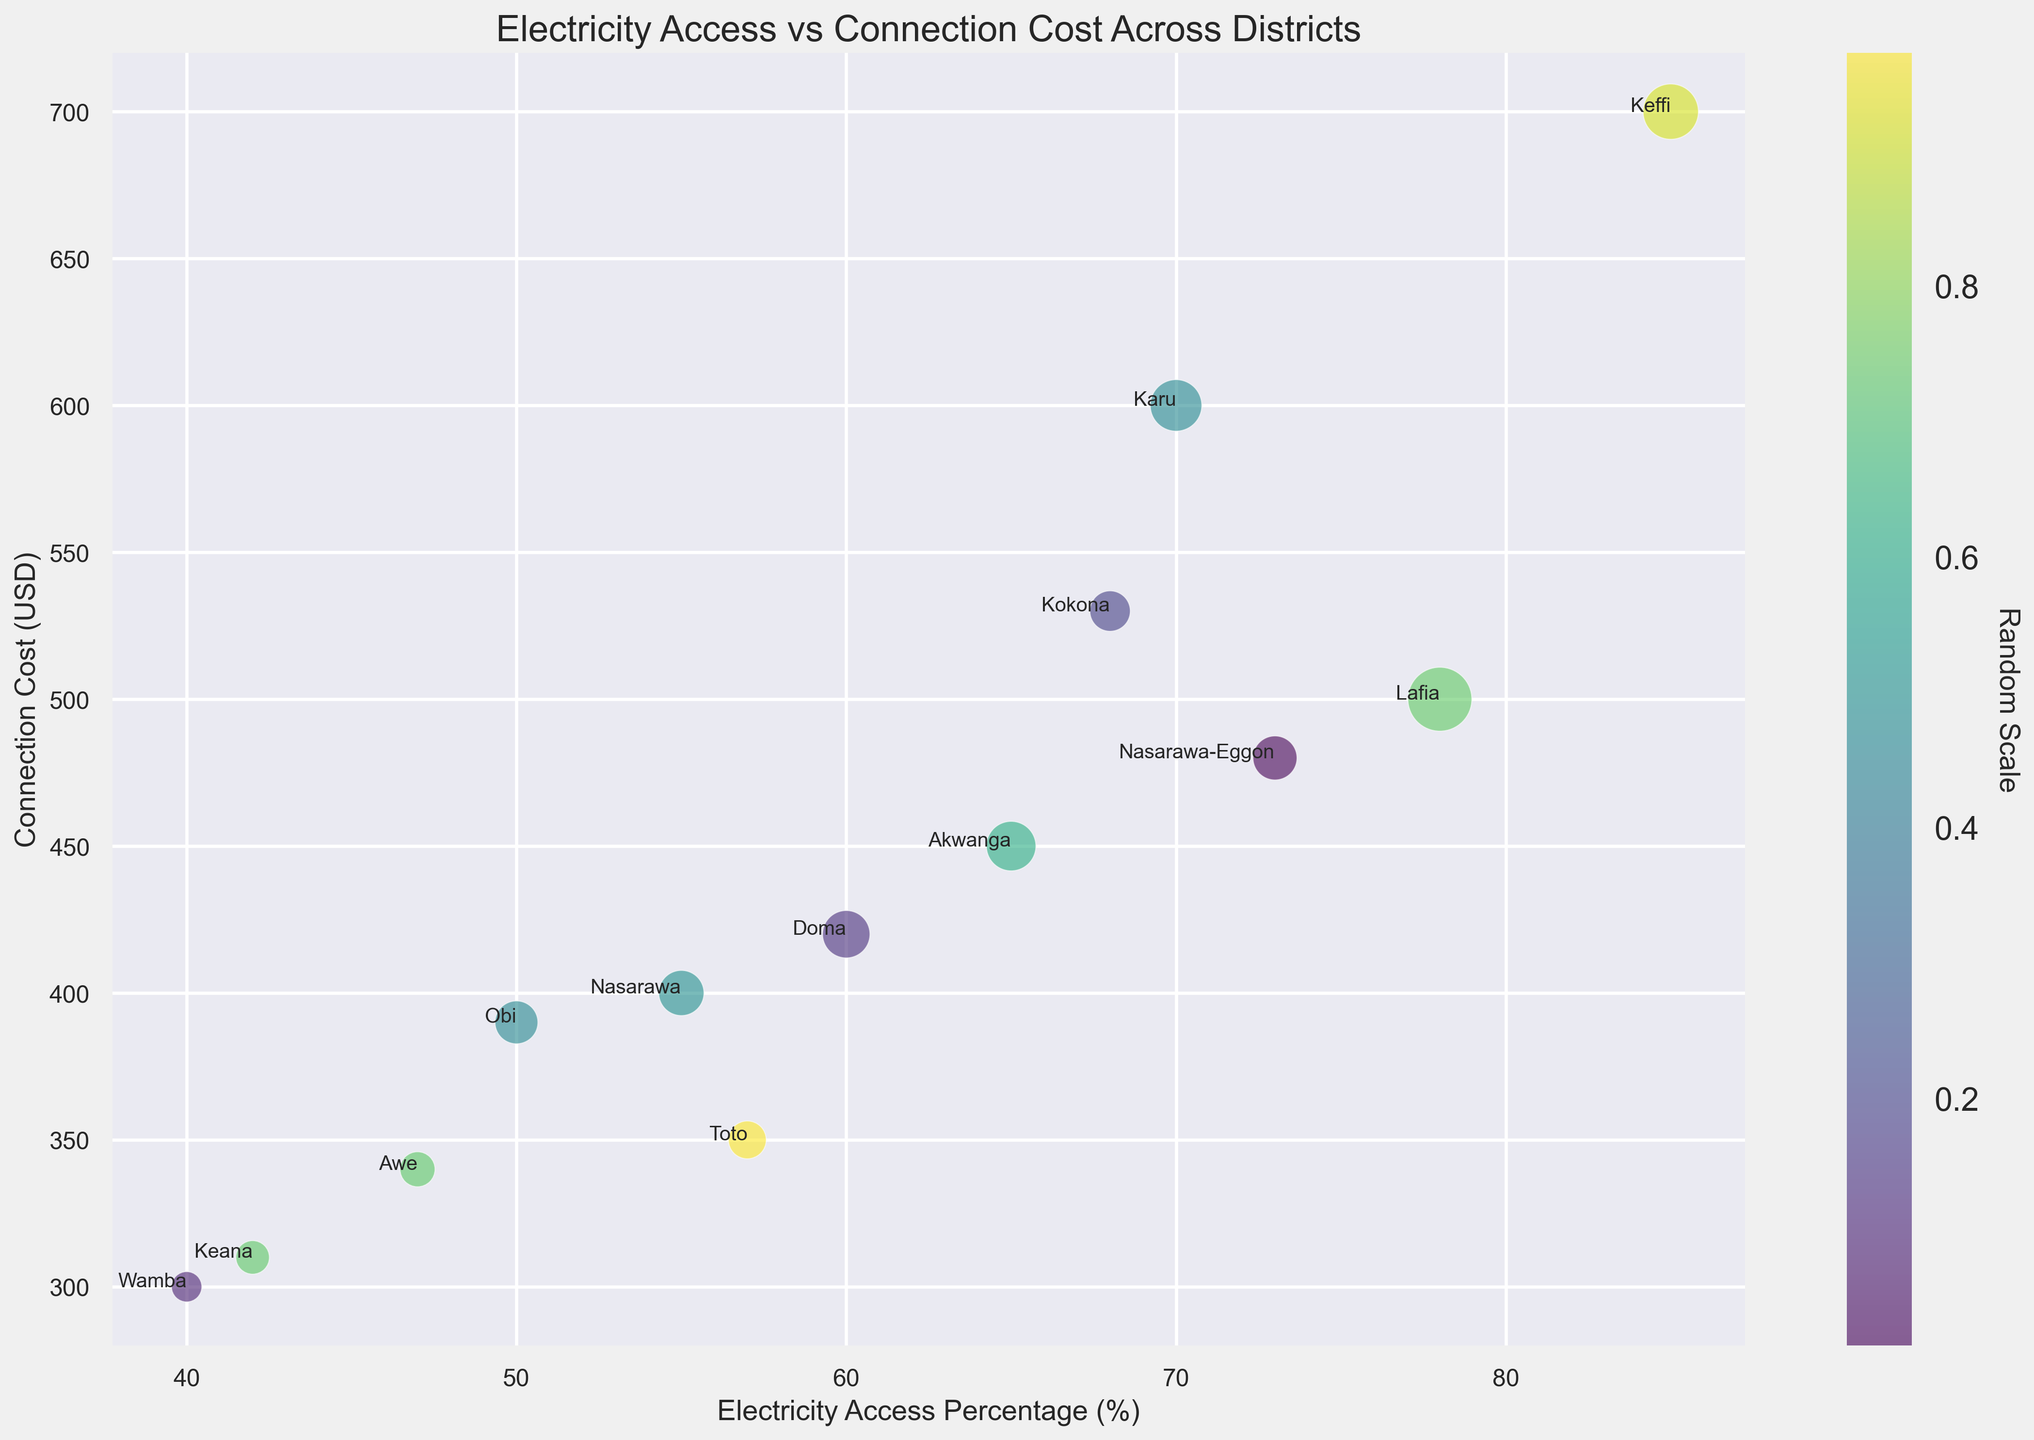What district has the highest electricity access percentage? By looking at the x-axis, we can see that Keffi has the highest electricity access percentage at 85%.
Answer: Keffi Which district has the highest connection cost, and what is that cost? By looking at the y-axis, we can see that Keffi has the highest connection cost at 700 USD.
Answer: Keffi, 700 USD Compare Lafia and Wamba in terms of electricity access percentage and connection cost. Which district has higher values for both? By looking at the coordinates, Lafia has an electricity access percentage of 78% and a connection cost of 500 USD, while Wamba has 40% and 300 USD respectively. Therefore, Lafia has higher values for both metrics.
Answer: Lafia What is the average connection cost for districts with more than 70% electricity access? The districts with more than 70% electricity access are Lafia (78%, 500 USD), Keffi (85%, 700 USD), and Nasarawa-Eggon (73%, 480 USD). The average connection cost is (500 + 700 + 480) / 3 = 560 USD.
Answer: 560 USD Which district has the largest bubble size, and what does that indicate? By looking at the bubble sizes, we can see that Lafia has the largest bubble, indicating it has the largest population of 200,000.
Answer: Lafia, largest population Is there any district with a lower connection cost than Awe, but a higher electricity access percentage? Awe has a connection cost of 340 USD and an electricity access percentage of 47%. Obi has a lower connection cost of 390 USD but a higher electricity access percentage of 50%.
Answer: Obi Between Toto and Kokona, which district has lower connection costs and what are the values? Toto has a connection cost of 350 USD, while Kokona has a connection cost of 530 USD. Therefore, Toto has the lower connection cost.
Answer: Toto, 350 USD Which district has the closest connection cost to the average connection cost of the state, and what are the two values? The average connection cost of all districts is (500 + 700 + 450 + 400 + 600 + 420 + 390 + 480 + 300 + 530 + 350 + 340 + 310) / 13 ≈ 460 USD. Akwanga, with a connection cost of 450 USD, is closest to the average.
Answer: Akwanga, 450 USD Which district has the lowest electricity access percentage, and what is the connection cost for that district? Wamba has the lowest electricity access percentage at 40%, and its connection cost is 300 USD.
Answer: Wamba, 300 USD 